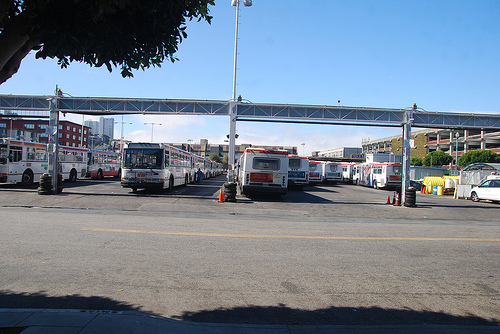On which side of the picture is the car? The car is actually located on the left side of the picture, juxtaposed against a backdrop of larger buses on the right. 